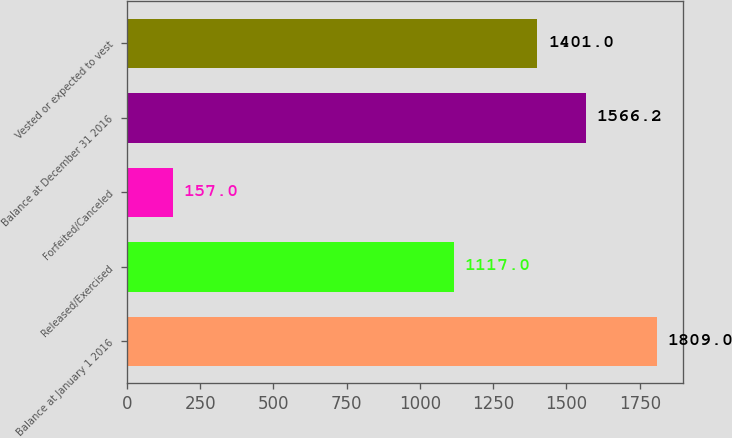<chart> <loc_0><loc_0><loc_500><loc_500><bar_chart><fcel>Balance at January 1 2016<fcel>Released/Exercised<fcel>Forfeited/Canceled<fcel>Balance at December 31 2016<fcel>Vested or expected to vest<nl><fcel>1809<fcel>1117<fcel>157<fcel>1566.2<fcel>1401<nl></chart> 